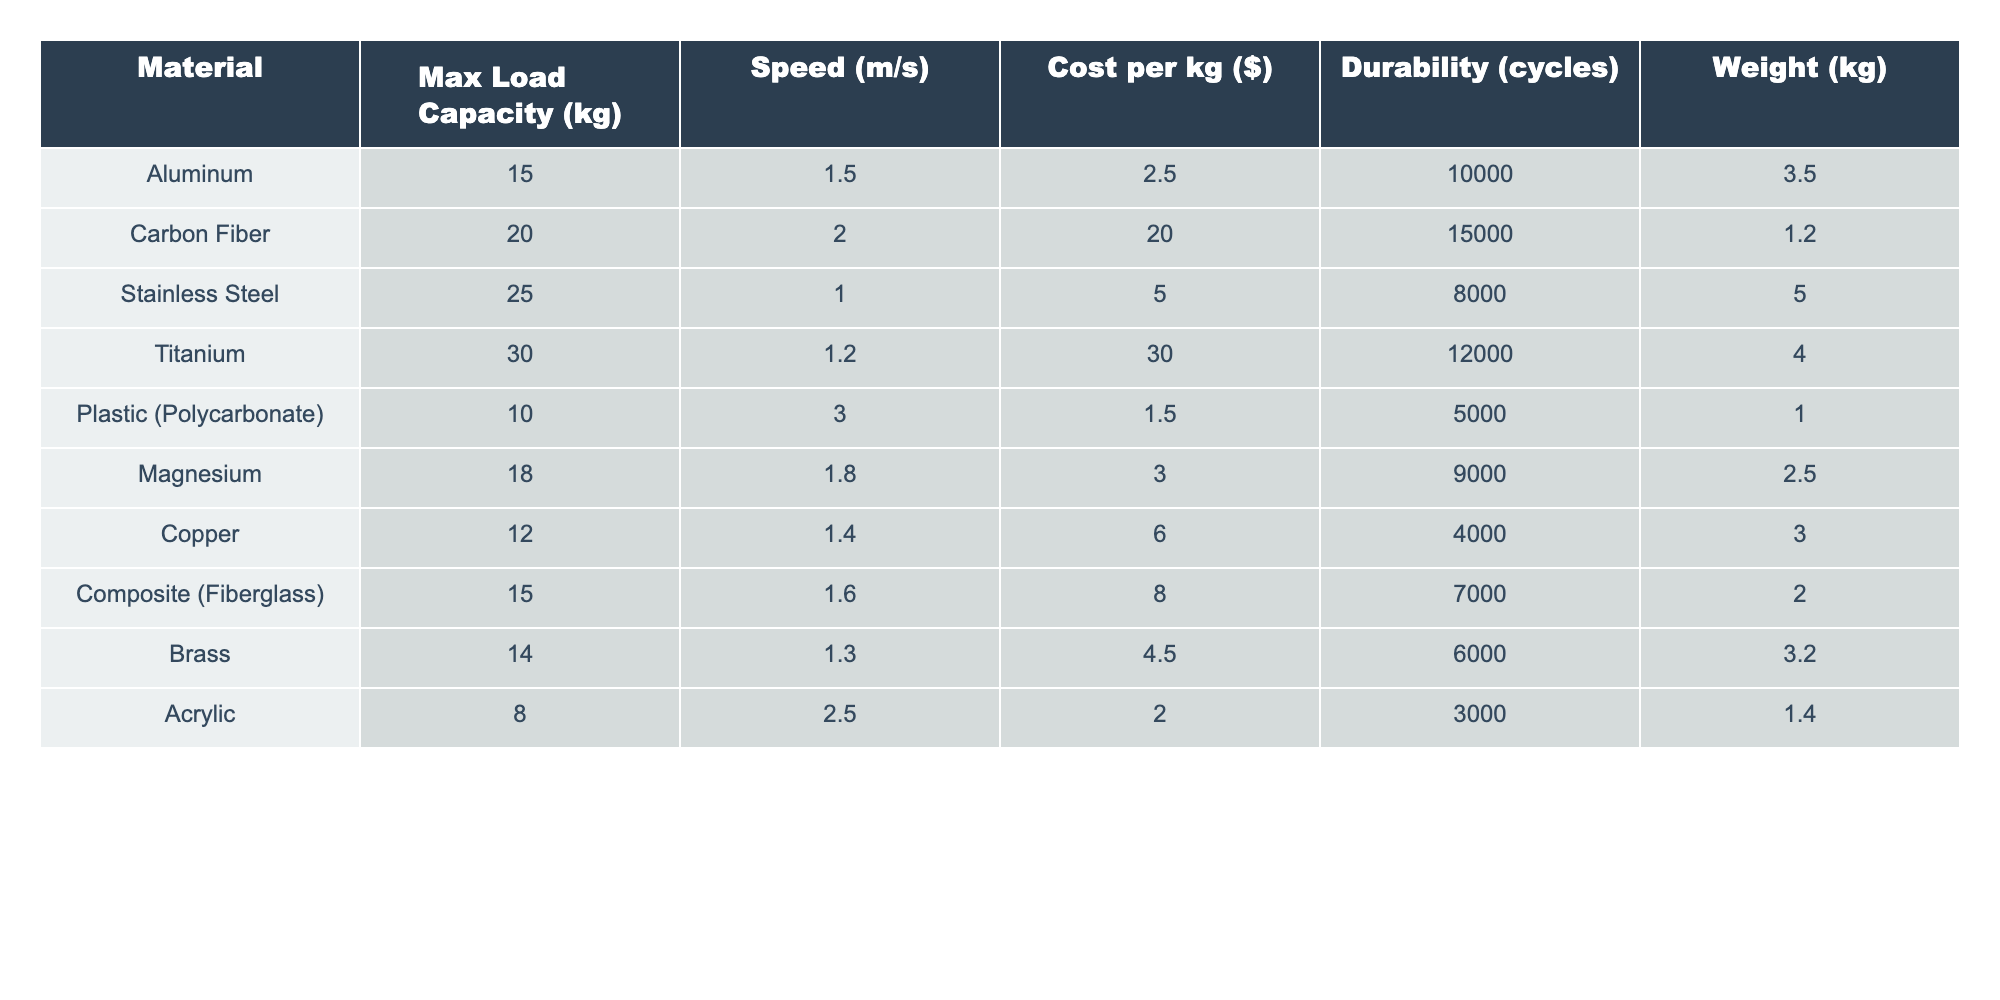What is the maximum load capacity of Titanium? The table shows the maximum load capacity for Titanium as 30 kg.
Answer: 30 kg Which material has the fastest speed? According to the table, Plastic (Polycarbonate) has the fastest speed at 3.0 m/s.
Answer: 3.0 m/s What is the cost per kg of Carbon Fiber? The table indicates that the cost per kg for Carbon Fiber is $20.00.
Answer: $20.00 Which material is the heaviest? By examining the "Weight" column, Stainless Steel has the highest weight at 5.0 kg.
Answer: 5.0 kg How many cycles can the Plastic (Polycarbonate) endure? The durability for Plastic (Polycarbonate) is shown to be 5000 cycles.
Answer: 5000 cycles Which material has a higher max load capacity, Aluminum or Brass? The max load capacity for Aluminum is 15 kg and for Brass is 14 kg, so Aluminum has a higher capacity.
Answer: Aluminum What is the average speed of all materials? The speeds are 1.5, 2.0, 1.0, 1.2, 3.0, 1.8, 1.4, 1.6, 1.3, and 2.5 m/s. Summing these speeds gives 16.0 m/s, and dividing by 10 materials yields an average speed of 1.6 m/s.
Answer: 1.6 m/s Is the load capacity for Copper greater than 15 kg? The maximum load capacity for Copper is 12 kg, which is less than 15 kg; therefore, the answer is no.
Answer: No Which material has the highest durability and what is its value? Titanium has the highest durability at 12000 cycles based on the table data.
Answer: 12000 cycles If you combine the max load capacities of Aluminum and Magnesium, what is the result? The max load capacity for Aluminum is 15 kg and Magnesium is 18 kg. Adding them together gives 15 + 18 = 33 kg.
Answer: 33 kg Which material costs less than $5 per kg? By checking the cost per kg of each material, Aluminum, Plastic (Polycarbonate), and Magnesium are all priced below $5.
Answer: Aluminum, Plastic (Polycarbonate), Magnesium 